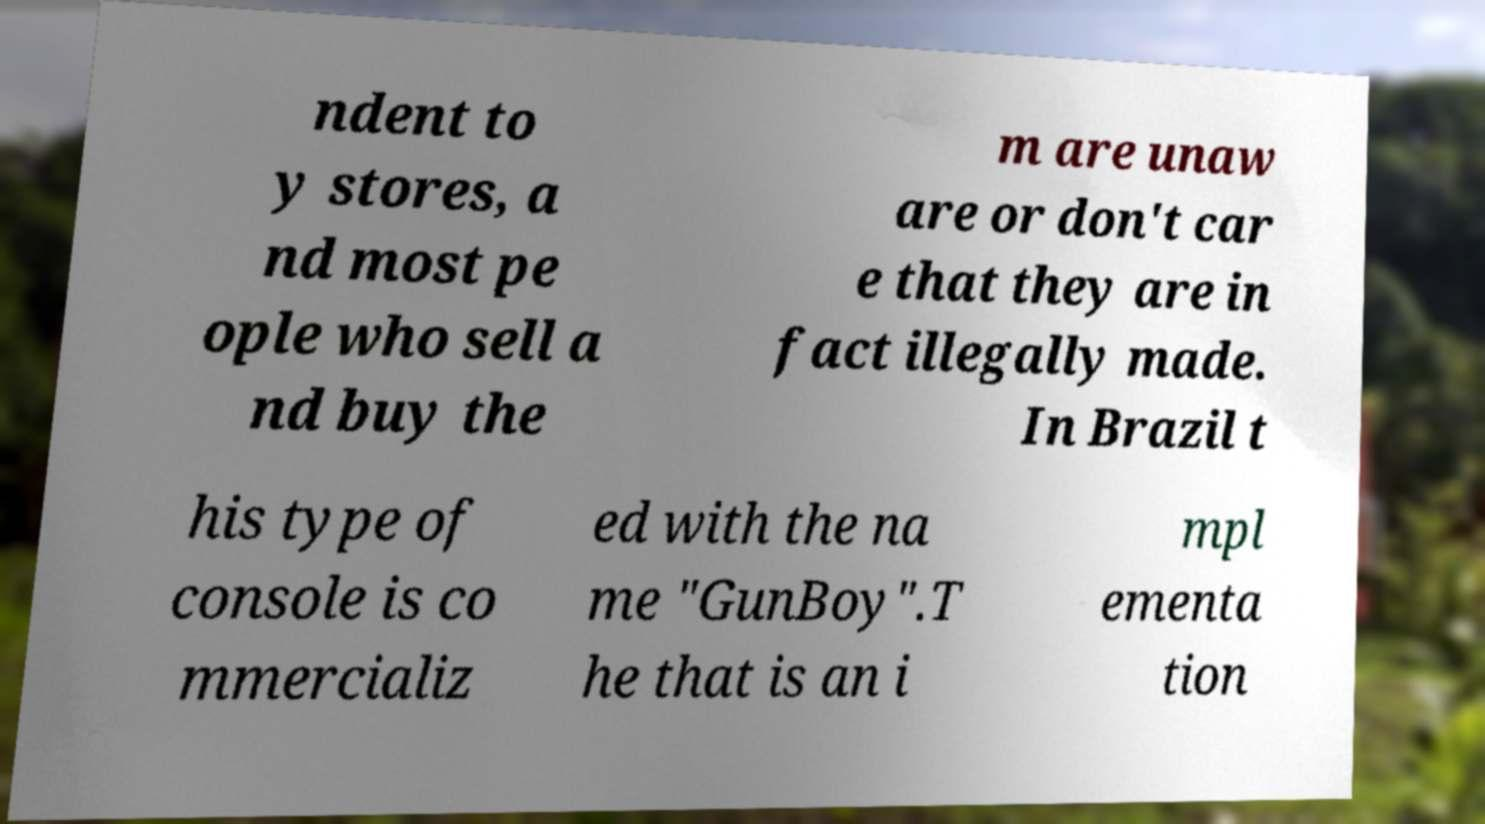For documentation purposes, I need the text within this image transcribed. Could you provide that? ndent to y stores, a nd most pe ople who sell a nd buy the m are unaw are or don't car e that they are in fact illegally made. In Brazil t his type of console is co mmercializ ed with the na me "GunBoy".T he that is an i mpl ementa tion 